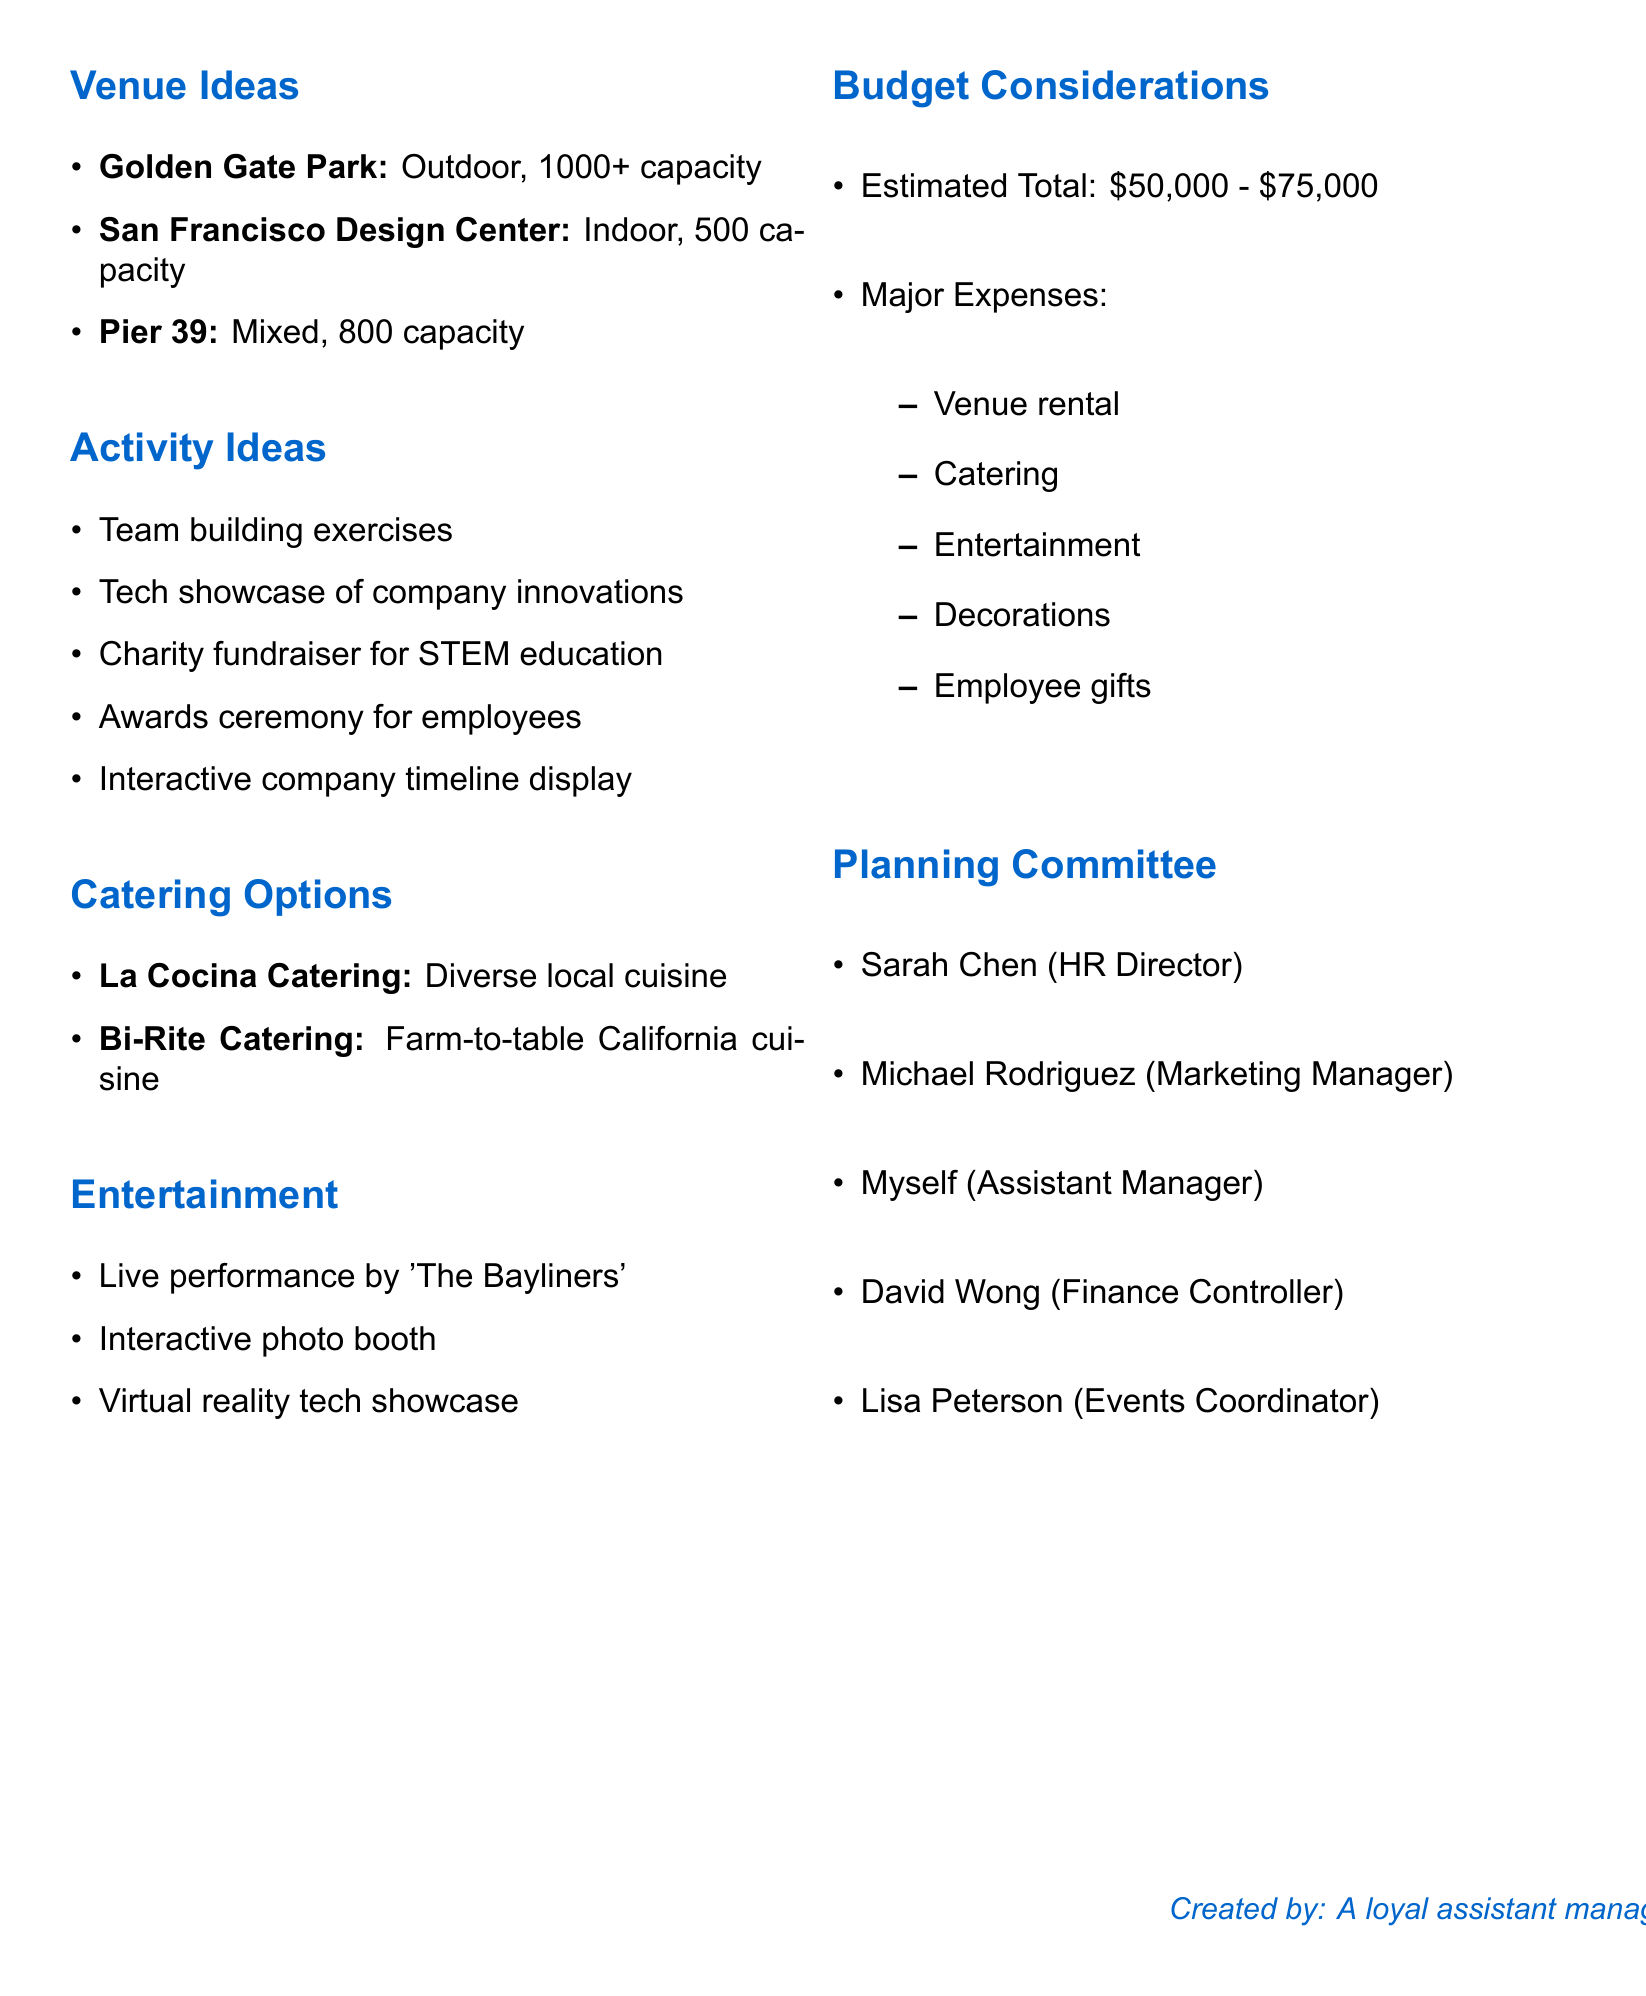What is the name of the company? The name of the company is mentioned at the beginning of the document, which is TechInnovate Solutions.
Answer: TechInnovate Solutions When was the company founded? The founding year is specified in the company details section of the document.
Answer: 2013 What is the estimated total budget for the celebration? The estimated total budget range is provided under budget considerations.
Answer: $50,000 - $75,000 How many venue ideas are listed? The total number of venue ideas can be counted in the venue ideas section.
Answer: 3 What type of cuisine does La Cocina Catering offer? La Cocina Catering's cuisine is specified in the catering options section.
Answer: Diverse local cuisine Which activity involves recognizing employees? The activity ideas section lists activities, and one specifically mentions recognizing employees.
Answer: Awards ceremony What is a special feature of Bi-Rite Catering? The catering options section includes special features for each catering option.
Answer: Emphasis on sustainability Which committee member is the HR Director? The planning committee section identifies each member's role, including the HR Director.
Answer: Sarah Chen What type of entertainment includes a live performance? The entertainment suggestions section mentions different forms of entertainment, including one that is a live performance.
Answer: Live performance by 'The Bayliners' 